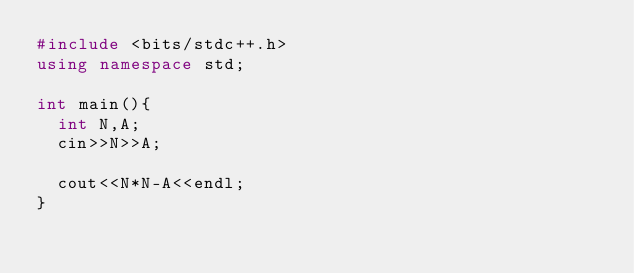<code> <loc_0><loc_0><loc_500><loc_500><_C++_>#include <bits/stdc++.h>
using namespace std;

int main(){
  int N,A;
  cin>>N>>A;
  
  cout<<N*N-A<<endl;
}</code> 